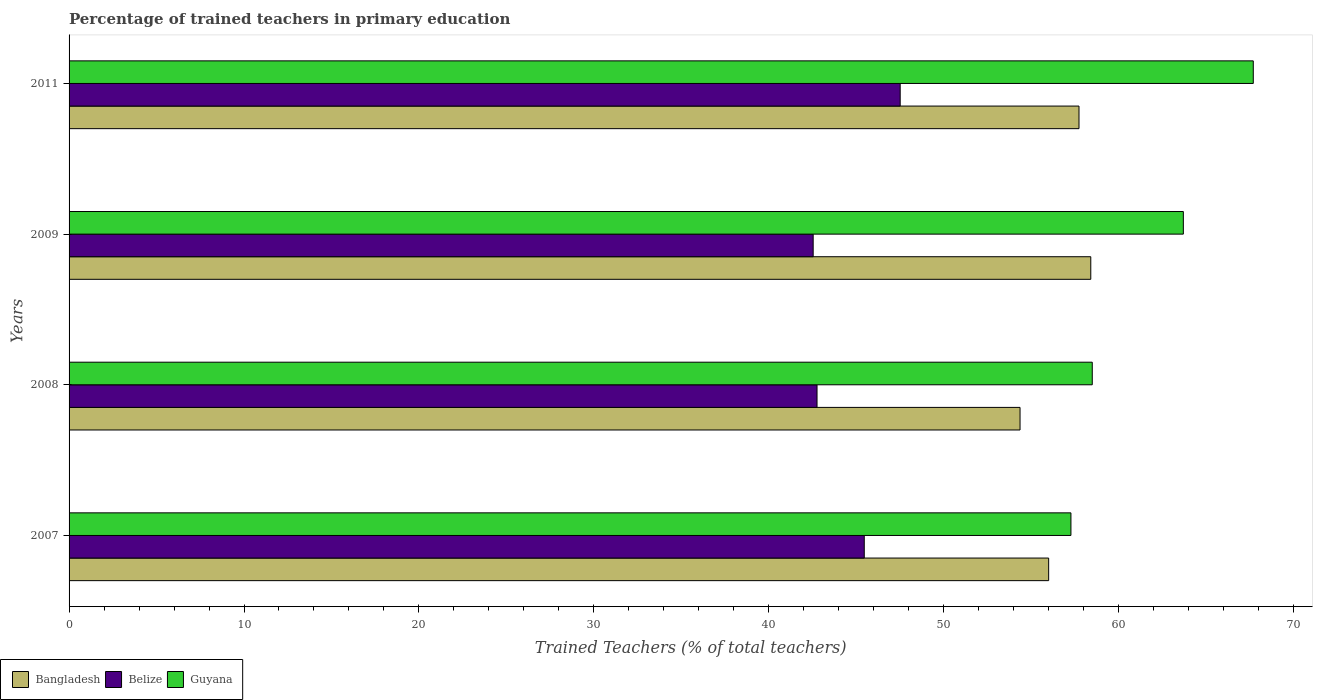How many different coloured bars are there?
Ensure brevity in your answer.  3. Are the number of bars per tick equal to the number of legend labels?
Ensure brevity in your answer.  Yes. Are the number of bars on each tick of the Y-axis equal?
Keep it short and to the point. Yes. How many bars are there on the 4th tick from the top?
Provide a short and direct response. 3. In how many cases, is the number of bars for a given year not equal to the number of legend labels?
Keep it short and to the point. 0. What is the percentage of trained teachers in Guyana in 2007?
Offer a very short reply. 57.27. Across all years, what is the maximum percentage of trained teachers in Guyana?
Make the answer very short. 67.7. Across all years, what is the minimum percentage of trained teachers in Bangladesh?
Offer a very short reply. 54.36. In which year was the percentage of trained teachers in Guyana maximum?
Make the answer very short. 2011. What is the total percentage of trained teachers in Bangladesh in the graph?
Your response must be concise. 226.5. What is the difference between the percentage of trained teachers in Bangladesh in 2008 and that in 2011?
Your answer should be compact. -3.37. What is the difference between the percentage of trained teachers in Belize in 2011 and the percentage of trained teachers in Bangladesh in 2007?
Provide a succinct answer. -8.49. What is the average percentage of trained teachers in Belize per year?
Your response must be concise. 44.57. In the year 2011, what is the difference between the percentage of trained teachers in Bangladesh and percentage of trained teachers in Guyana?
Provide a succinct answer. -9.96. In how many years, is the percentage of trained teachers in Bangladesh greater than 4 %?
Your response must be concise. 4. What is the ratio of the percentage of trained teachers in Bangladesh in 2007 to that in 2008?
Your response must be concise. 1.03. What is the difference between the highest and the second highest percentage of trained teachers in Bangladesh?
Ensure brevity in your answer.  0.67. What is the difference between the highest and the lowest percentage of trained teachers in Bangladesh?
Ensure brevity in your answer.  4.04. Is the sum of the percentage of trained teachers in Belize in 2008 and 2011 greater than the maximum percentage of trained teachers in Bangladesh across all years?
Ensure brevity in your answer.  Yes. What does the 3rd bar from the bottom in 2008 represents?
Provide a succinct answer. Guyana. How many bars are there?
Make the answer very short. 12. Are all the bars in the graph horizontal?
Ensure brevity in your answer.  Yes. Are the values on the major ticks of X-axis written in scientific E-notation?
Your answer should be compact. No. Where does the legend appear in the graph?
Provide a succinct answer. Bottom left. How many legend labels are there?
Provide a short and direct response. 3. What is the title of the graph?
Provide a short and direct response. Percentage of trained teachers in primary education. What is the label or title of the X-axis?
Your response must be concise. Trained Teachers (% of total teachers). What is the label or title of the Y-axis?
Provide a short and direct response. Years. What is the Trained Teachers (% of total teachers) of Bangladesh in 2007?
Offer a terse response. 56. What is the Trained Teachers (% of total teachers) in Belize in 2007?
Provide a short and direct response. 45.46. What is the Trained Teachers (% of total teachers) in Guyana in 2007?
Offer a very short reply. 57.27. What is the Trained Teachers (% of total teachers) of Bangladesh in 2008?
Provide a succinct answer. 54.36. What is the Trained Teachers (% of total teachers) in Belize in 2008?
Give a very brief answer. 42.76. What is the Trained Teachers (% of total teachers) in Guyana in 2008?
Provide a short and direct response. 58.49. What is the Trained Teachers (% of total teachers) of Bangladesh in 2009?
Your response must be concise. 58.41. What is the Trained Teachers (% of total teachers) in Belize in 2009?
Make the answer very short. 42.54. What is the Trained Teachers (% of total teachers) in Guyana in 2009?
Keep it short and to the point. 63.7. What is the Trained Teachers (% of total teachers) of Bangladesh in 2011?
Offer a very short reply. 57.73. What is the Trained Teachers (% of total teachers) in Belize in 2011?
Ensure brevity in your answer.  47.51. What is the Trained Teachers (% of total teachers) of Guyana in 2011?
Provide a short and direct response. 67.7. Across all years, what is the maximum Trained Teachers (% of total teachers) of Bangladesh?
Make the answer very short. 58.41. Across all years, what is the maximum Trained Teachers (% of total teachers) of Belize?
Ensure brevity in your answer.  47.51. Across all years, what is the maximum Trained Teachers (% of total teachers) in Guyana?
Provide a short and direct response. 67.7. Across all years, what is the minimum Trained Teachers (% of total teachers) in Bangladesh?
Offer a very short reply. 54.36. Across all years, what is the minimum Trained Teachers (% of total teachers) of Belize?
Keep it short and to the point. 42.54. Across all years, what is the minimum Trained Teachers (% of total teachers) of Guyana?
Your response must be concise. 57.27. What is the total Trained Teachers (% of total teachers) in Bangladesh in the graph?
Your answer should be very brief. 226.5. What is the total Trained Teachers (% of total teachers) of Belize in the graph?
Offer a terse response. 178.27. What is the total Trained Teachers (% of total teachers) of Guyana in the graph?
Ensure brevity in your answer.  247.16. What is the difference between the Trained Teachers (% of total teachers) in Bangladesh in 2007 and that in 2008?
Make the answer very short. 1.64. What is the difference between the Trained Teachers (% of total teachers) of Belize in 2007 and that in 2008?
Your answer should be compact. 2.7. What is the difference between the Trained Teachers (% of total teachers) in Guyana in 2007 and that in 2008?
Offer a very short reply. -1.22. What is the difference between the Trained Teachers (% of total teachers) of Bangladesh in 2007 and that in 2009?
Your answer should be compact. -2.41. What is the difference between the Trained Teachers (% of total teachers) in Belize in 2007 and that in 2009?
Ensure brevity in your answer.  2.92. What is the difference between the Trained Teachers (% of total teachers) in Guyana in 2007 and that in 2009?
Keep it short and to the point. -6.43. What is the difference between the Trained Teachers (% of total teachers) in Bangladesh in 2007 and that in 2011?
Your answer should be compact. -1.74. What is the difference between the Trained Teachers (% of total teachers) in Belize in 2007 and that in 2011?
Provide a short and direct response. -2.05. What is the difference between the Trained Teachers (% of total teachers) of Guyana in 2007 and that in 2011?
Your answer should be compact. -10.42. What is the difference between the Trained Teachers (% of total teachers) in Bangladesh in 2008 and that in 2009?
Provide a succinct answer. -4.04. What is the difference between the Trained Teachers (% of total teachers) in Belize in 2008 and that in 2009?
Your answer should be very brief. 0.22. What is the difference between the Trained Teachers (% of total teachers) of Guyana in 2008 and that in 2009?
Your answer should be very brief. -5.21. What is the difference between the Trained Teachers (% of total teachers) in Bangladesh in 2008 and that in 2011?
Provide a succinct answer. -3.37. What is the difference between the Trained Teachers (% of total teachers) in Belize in 2008 and that in 2011?
Ensure brevity in your answer.  -4.75. What is the difference between the Trained Teachers (% of total teachers) in Guyana in 2008 and that in 2011?
Keep it short and to the point. -9.21. What is the difference between the Trained Teachers (% of total teachers) of Bangladesh in 2009 and that in 2011?
Ensure brevity in your answer.  0.67. What is the difference between the Trained Teachers (% of total teachers) of Belize in 2009 and that in 2011?
Your answer should be compact. -4.97. What is the difference between the Trained Teachers (% of total teachers) in Guyana in 2009 and that in 2011?
Your answer should be compact. -4. What is the difference between the Trained Teachers (% of total teachers) in Bangladesh in 2007 and the Trained Teachers (% of total teachers) in Belize in 2008?
Offer a very short reply. 13.24. What is the difference between the Trained Teachers (% of total teachers) of Bangladesh in 2007 and the Trained Teachers (% of total teachers) of Guyana in 2008?
Ensure brevity in your answer.  -2.49. What is the difference between the Trained Teachers (% of total teachers) of Belize in 2007 and the Trained Teachers (% of total teachers) of Guyana in 2008?
Offer a very short reply. -13.03. What is the difference between the Trained Teachers (% of total teachers) of Bangladesh in 2007 and the Trained Teachers (% of total teachers) of Belize in 2009?
Offer a very short reply. 13.46. What is the difference between the Trained Teachers (% of total teachers) in Bangladesh in 2007 and the Trained Teachers (% of total teachers) in Guyana in 2009?
Ensure brevity in your answer.  -7.7. What is the difference between the Trained Teachers (% of total teachers) of Belize in 2007 and the Trained Teachers (% of total teachers) of Guyana in 2009?
Make the answer very short. -18.24. What is the difference between the Trained Teachers (% of total teachers) in Bangladesh in 2007 and the Trained Teachers (% of total teachers) in Belize in 2011?
Your answer should be very brief. 8.49. What is the difference between the Trained Teachers (% of total teachers) in Bangladesh in 2007 and the Trained Teachers (% of total teachers) in Guyana in 2011?
Provide a short and direct response. -11.7. What is the difference between the Trained Teachers (% of total teachers) of Belize in 2007 and the Trained Teachers (% of total teachers) of Guyana in 2011?
Provide a succinct answer. -22.24. What is the difference between the Trained Teachers (% of total teachers) in Bangladesh in 2008 and the Trained Teachers (% of total teachers) in Belize in 2009?
Provide a succinct answer. 11.83. What is the difference between the Trained Teachers (% of total teachers) in Bangladesh in 2008 and the Trained Teachers (% of total teachers) in Guyana in 2009?
Offer a terse response. -9.34. What is the difference between the Trained Teachers (% of total teachers) in Belize in 2008 and the Trained Teachers (% of total teachers) in Guyana in 2009?
Your answer should be very brief. -20.94. What is the difference between the Trained Teachers (% of total teachers) in Bangladesh in 2008 and the Trained Teachers (% of total teachers) in Belize in 2011?
Ensure brevity in your answer.  6.85. What is the difference between the Trained Teachers (% of total teachers) of Bangladesh in 2008 and the Trained Teachers (% of total teachers) of Guyana in 2011?
Provide a short and direct response. -13.33. What is the difference between the Trained Teachers (% of total teachers) in Belize in 2008 and the Trained Teachers (% of total teachers) in Guyana in 2011?
Offer a terse response. -24.94. What is the difference between the Trained Teachers (% of total teachers) of Bangladesh in 2009 and the Trained Teachers (% of total teachers) of Belize in 2011?
Give a very brief answer. 10.9. What is the difference between the Trained Teachers (% of total teachers) in Bangladesh in 2009 and the Trained Teachers (% of total teachers) in Guyana in 2011?
Give a very brief answer. -9.29. What is the difference between the Trained Teachers (% of total teachers) in Belize in 2009 and the Trained Teachers (% of total teachers) in Guyana in 2011?
Provide a short and direct response. -25.16. What is the average Trained Teachers (% of total teachers) of Bangladesh per year?
Your answer should be compact. 56.63. What is the average Trained Teachers (% of total teachers) in Belize per year?
Provide a succinct answer. 44.57. What is the average Trained Teachers (% of total teachers) in Guyana per year?
Make the answer very short. 61.79. In the year 2007, what is the difference between the Trained Teachers (% of total teachers) of Bangladesh and Trained Teachers (% of total teachers) of Belize?
Provide a short and direct response. 10.54. In the year 2007, what is the difference between the Trained Teachers (% of total teachers) of Bangladesh and Trained Teachers (% of total teachers) of Guyana?
Provide a short and direct response. -1.27. In the year 2007, what is the difference between the Trained Teachers (% of total teachers) in Belize and Trained Teachers (% of total teachers) in Guyana?
Give a very brief answer. -11.81. In the year 2008, what is the difference between the Trained Teachers (% of total teachers) of Bangladesh and Trained Teachers (% of total teachers) of Belize?
Provide a short and direct response. 11.61. In the year 2008, what is the difference between the Trained Teachers (% of total teachers) in Bangladesh and Trained Teachers (% of total teachers) in Guyana?
Provide a succinct answer. -4.13. In the year 2008, what is the difference between the Trained Teachers (% of total teachers) of Belize and Trained Teachers (% of total teachers) of Guyana?
Ensure brevity in your answer.  -15.73. In the year 2009, what is the difference between the Trained Teachers (% of total teachers) of Bangladesh and Trained Teachers (% of total teachers) of Belize?
Offer a very short reply. 15.87. In the year 2009, what is the difference between the Trained Teachers (% of total teachers) of Bangladesh and Trained Teachers (% of total teachers) of Guyana?
Provide a short and direct response. -5.29. In the year 2009, what is the difference between the Trained Teachers (% of total teachers) in Belize and Trained Teachers (% of total teachers) in Guyana?
Ensure brevity in your answer.  -21.16. In the year 2011, what is the difference between the Trained Teachers (% of total teachers) of Bangladesh and Trained Teachers (% of total teachers) of Belize?
Keep it short and to the point. 10.22. In the year 2011, what is the difference between the Trained Teachers (% of total teachers) in Bangladesh and Trained Teachers (% of total teachers) in Guyana?
Provide a succinct answer. -9.96. In the year 2011, what is the difference between the Trained Teachers (% of total teachers) in Belize and Trained Teachers (% of total teachers) in Guyana?
Offer a very short reply. -20.19. What is the ratio of the Trained Teachers (% of total teachers) of Bangladesh in 2007 to that in 2008?
Your answer should be very brief. 1.03. What is the ratio of the Trained Teachers (% of total teachers) of Belize in 2007 to that in 2008?
Give a very brief answer. 1.06. What is the ratio of the Trained Teachers (% of total teachers) of Guyana in 2007 to that in 2008?
Offer a terse response. 0.98. What is the ratio of the Trained Teachers (% of total teachers) in Bangladesh in 2007 to that in 2009?
Make the answer very short. 0.96. What is the ratio of the Trained Teachers (% of total teachers) of Belize in 2007 to that in 2009?
Ensure brevity in your answer.  1.07. What is the ratio of the Trained Teachers (% of total teachers) in Guyana in 2007 to that in 2009?
Make the answer very short. 0.9. What is the ratio of the Trained Teachers (% of total teachers) of Bangladesh in 2007 to that in 2011?
Your response must be concise. 0.97. What is the ratio of the Trained Teachers (% of total teachers) of Belize in 2007 to that in 2011?
Your response must be concise. 0.96. What is the ratio of the Trained Teachers (% of total teachers) in Guyana in 2007 to that in 2011?
Your answer should be very brief. 0.85. What is the ratio of the Trained Teachers (% of total teachers) of Bangladesh in 2008 to that in 2009?
Your answer should be very brief. 0.93. What is the ratio of the Trained Teachers (% of total teachers) in Belize in 2008 to that in 2009?
Offer a terse response. 1.01. What is the ratio of the Trained Teachers (% of total teachers) in Guyana in 2008 to that in 2009?
Your response must be concise. 0.92. What is the ratio of the Trained Teachers (% of total teachers) of Bangladesh in 2008 to that in 2011?
Give a very brief answer. 0.94. What is the ratio of the Trained Teachers (% of total teachers) in Belize in 2008 to that in 2011?
Keep it short and to the point. 0.9. What is the ratio of the Trained Teachers (% of total teachers) of Guyana in 2008 to that in 2011?
Ensure brevity in your answer.  0.86. What is the ratio of the Trained Teachers (% of total teachers) of Bangladesh in 2009 to that in 2011?
Provide a succinct answer. 1.01. What is the ratio of the Trained Teachers (% of total teachers) in Belize in 2009 to that in 2011?
Keep it short and to the point. 0.9. What is the ratio of the Trained Teachers (% of total teachers) in Guyana in 2009 to that in 2011?
Your response must be concise. 0.94. What is the difference between the highest and the second highest Trained Teachers (% of total teachers) of Bangladesh?
Give a very brief answer. 0.67. What is the difference between the highest and the second highest Trained Teachers (% of total teachers) in Belize?
Your answer should be compact. 2.05. What is the difference between the highest and the second highest Trained Teachers (% of total teachers) in Guyana?
Keep it short and to the point. 4. What is the difference between the highest and the lowest Trained Teachers (% of total teachers) of Bangladesh?
Your answer should be compact. 4.04. What is the difference between the highest and the lowest Trained Teachers (% of total teachers) of Belize?
Offer a very short reply. 4.97. What is the difference between the highest and the lowest Trained Teachers (% of total teachers) in Guyana?
Your answer should be very brief. 10.42. 